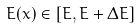<formula> <loc_0><loc_0><loc_500><loc_500>E ( x ) \in [ E , E + \Delta E ]</formula> 